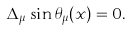Convert formula to latex. <formula><loc_0><loc_0><loc_500><loc_500>\Delta _ { \mu } \sin \theta _ { \mu } ( x ) = 0 .</formula> 